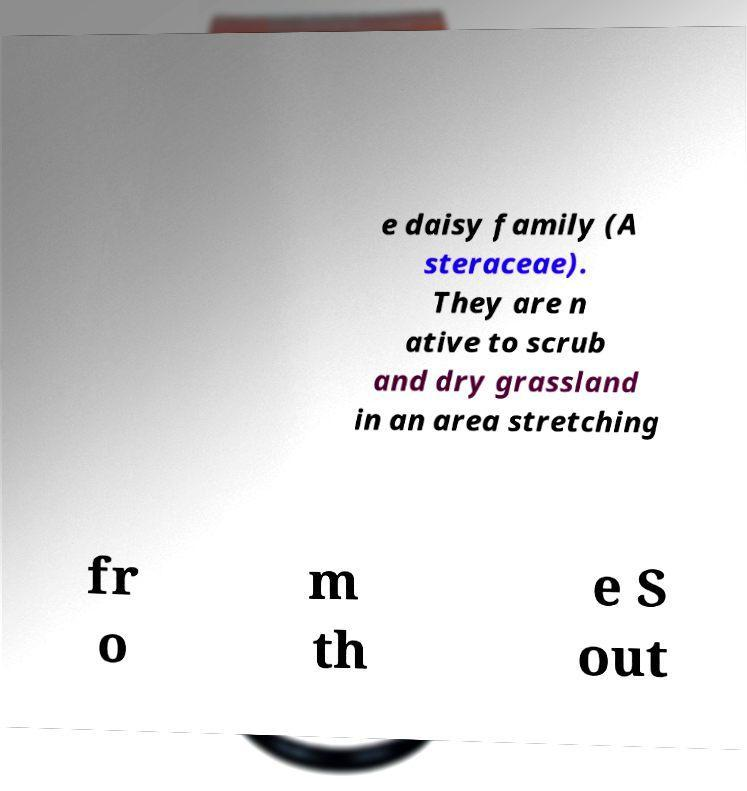Please read and relay the text visible in this image. What does it say? e daisy family (A steraceae). They are n ative to scrub and dry grassland in an area stretching fr o m th e S out 